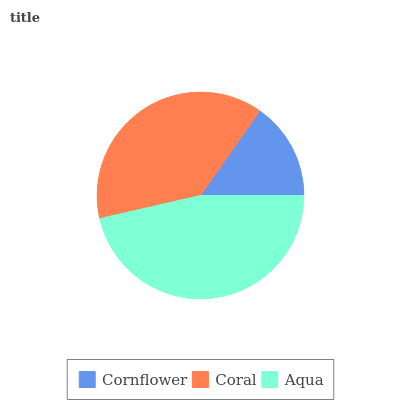Is Cornflower the minimum?
Answer yes or no. Yes. Is Aqua the maximum?
Answer yes or no. Yes. Is Coral the minimum?
Answer yes or no. No. Is Coral the maximum?
Answer yes or no. No. Is Coral greater than Cornflower?
Answer yes or no. Yes. Is Cornflower less than Coral?
Answer yes or no. Yes. Is Cornflower greater than Coral?
Answer yes or no. No. Is Coral less than Cornflower?
Answer yes or no. No. Is Coral the high median?
Answer yes or no. Yes. Is Coral the low median?
Answer yes or no. Yes. Is Cornflower the high median?
Answer yes or no. No. Is Cornflower the low median?
Answer yes or no. No. 